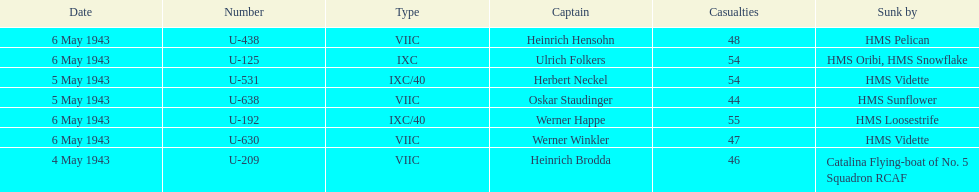How many captains are listed? 7. 